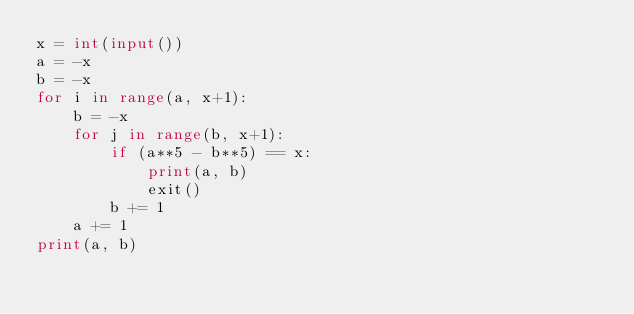<code> <loc_0><loc_0><loc_500><loc_500><_Python_>x = int(input())
a = -x
b = -x
for i in range(a, x+1):
    b = -x
    for j in range(b, x+1):
        if (a**5 - b**5) == x:
            print(a, b)
            exit()
        b += 1
    a += 1
print(a, b)</code> 